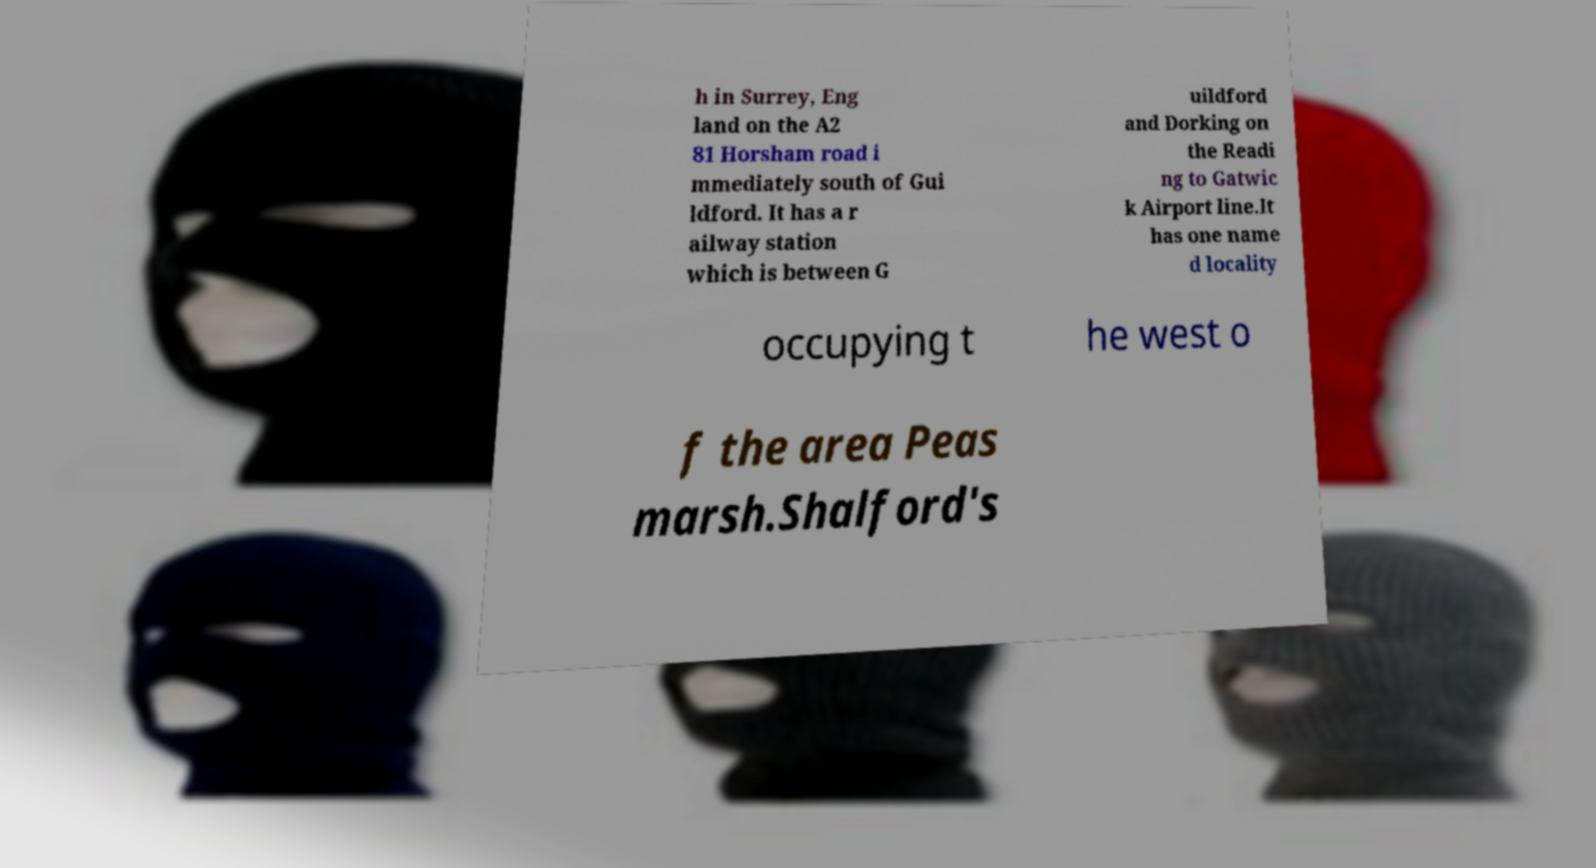Could you extract and type out the text from this image? h in Surrey, Eng land on the A2 81 Horsham road i mmediately south of Gui ldford. It has a r ailway station which is between G uildford and Dorking on the Readi ng to Gatwic k Airport line.It has one name d locality occupying t he west o f the area Peas marsh.Shalford's 